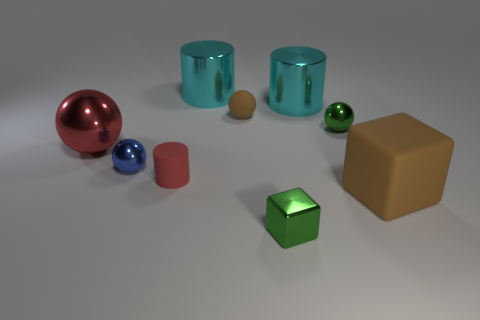What size is the matte thing that is the same color as the big rubber block?
Your answer should be very brief. Small. What shape is the metal object that is the same color as the tiny block?
Ensure brevity in your answer.  Sphere. There is a large cyan metal thing in front of the shiny cylinder that is behind the cyan thing on the right side of the tiny cube; what shape is it?
Give a very brief answer. Cylinder. How many other things are the same shape as the large red thing?
Make the answer very short. 3. What number of metallic things are either cyan cylinders or tiny green things?
Your answer should be compact. 4. There is a cube on the left side of the large cyan shiny thing on the right side of the green metal cube; what is it made of?
Ensure brevity in your answer.  Metal. Is the number of small red matte things on the right side of the tiny green sphere greater than the number of small blue spheres?
Your answer should be very brief. No. Is there a small cube that has the same material as the small green ball?
Provide a succinct answer. Yes. Is the shape of the small green thing that is in front of the matte cube the same as  the tiny brown matte object?
Make the answer very short. No. There is a small sphere that is on the left side of the small matte thing that is behind the red rubber thing; how many red spheres are in front of it?
Keep it short and to the point. 0. 